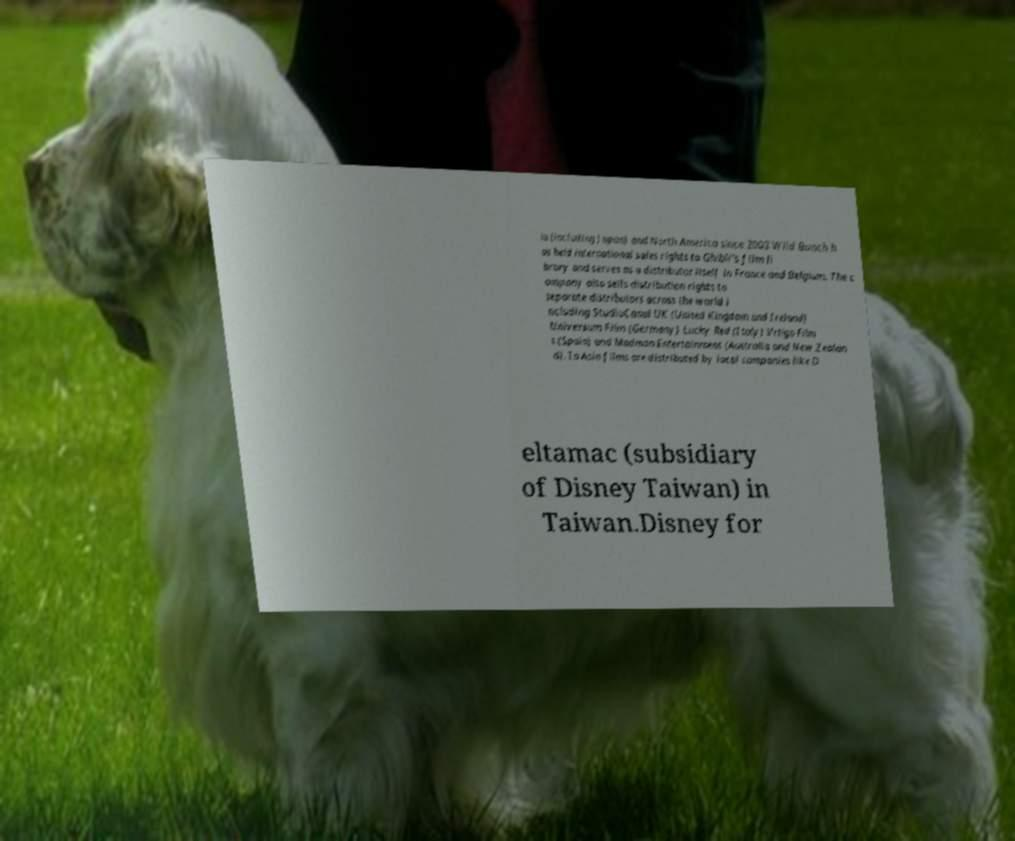For documentation purposes, I need the text within this image transcribed. Could you provide that? ia (including Japan) and North America since 2003 Wild Bunch h as held international sales rights to Ghibli's film li brary and serves as a distributor itself in France and Belgium. The c ompany also sells distribution rights to separate distributors across the world i ncluding StudioCanal UK (United Kingdom and Ireland) Universum Film (Germany) Lucky Red (Italy) Vrtigo Film s (Spain) and Madman Entertainment (Australia and New Zealan d). In Asia films are distributed by local companies like D eltamac (subsidiary of Disney Taiwan) in Taiwan.Disney for 